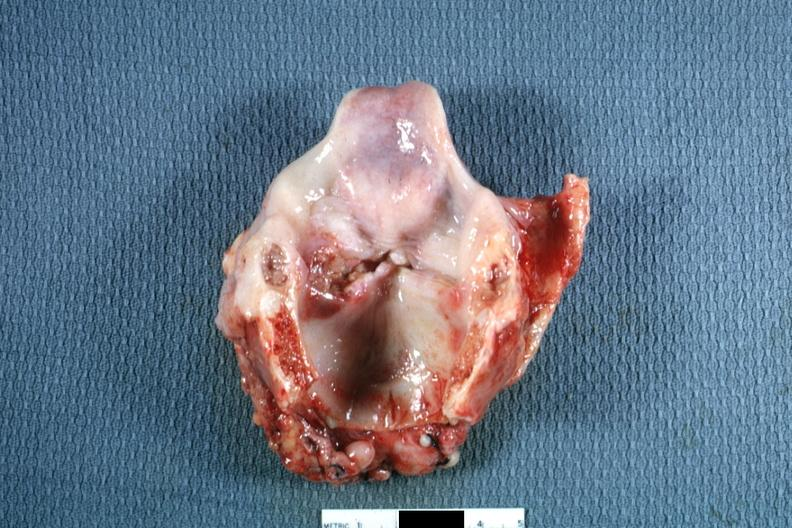what left true cord quite good?
Answer the question using a single word or phrase. Ulcerative lesion 